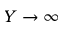Convert formula to latex. <formula><loc_0><loc_0><loc_500><loc_500>Y \rightarrow \infty</formula> 